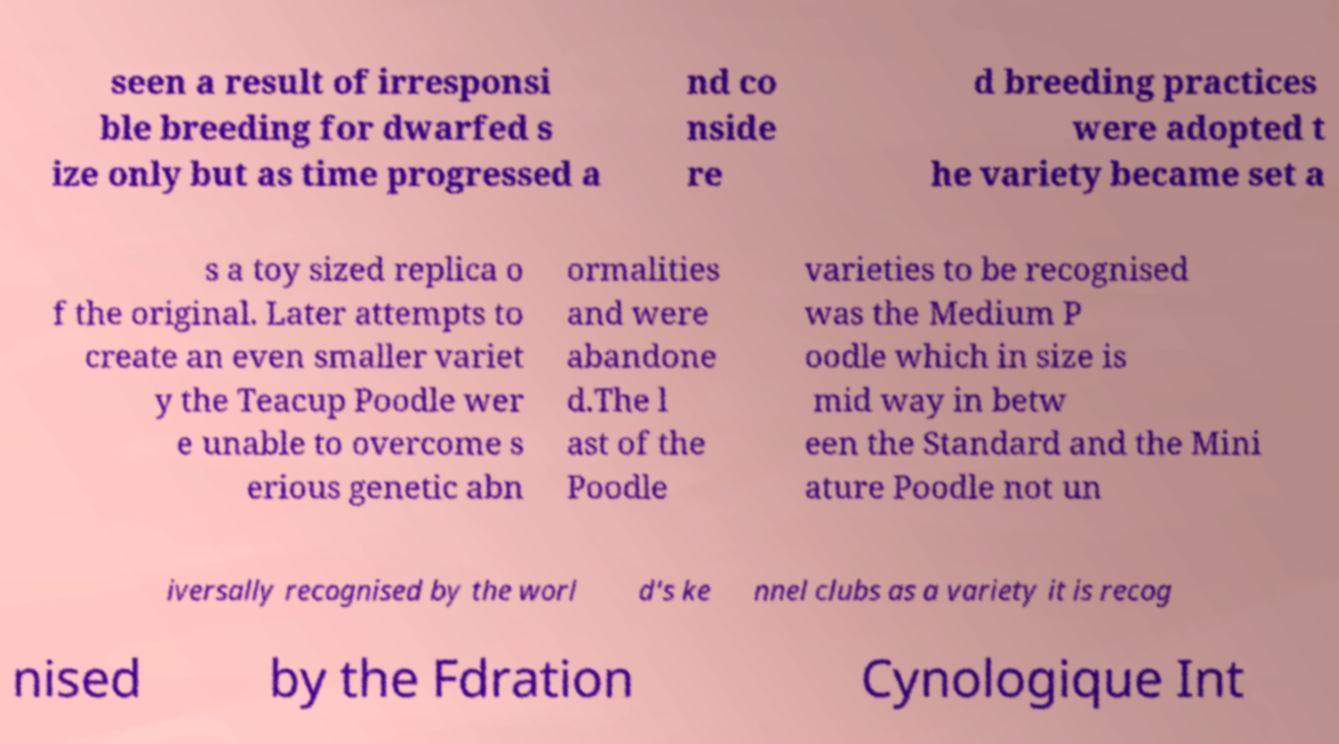There's text embedded in this image that I need extracted. Can you transcribe it verbatim? seen a result of irresponsi ble breeding for dwarfed s ize only but as time progressed a nd co nside re d breeding practices were adopted t he variety became set a s a toy sized replica o f the original. Later attempts to create an even smaller variet y the Teacup Poodle wer e unable to overcome s erious genetic abn ormalities and were abandone d.The l ast of the Poodle varieties to be recognised was the Medium P oodle which in size is mid way in betw een the Standard and the Mini ature Poodle not un iversally recognised by the worl d's ke nnel clubs as a variety it is recog nised by the Fdration Cynologique Int 